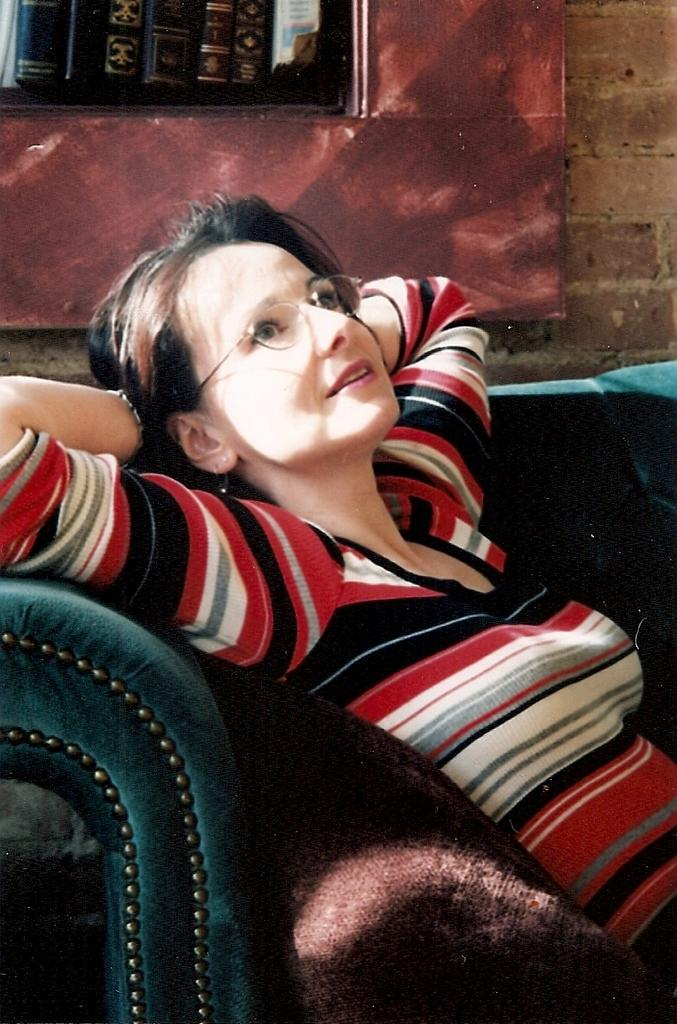Who is present in the image? There is a woman in the image. What is the woman doing in the image? The woman is sitting on a couch. What can be seen in the background of the image? There are books and a wall in the background of the image. What type of punishment is the woman receiving in the image? There is no indication in the image that the woman is receiving any punishment. 